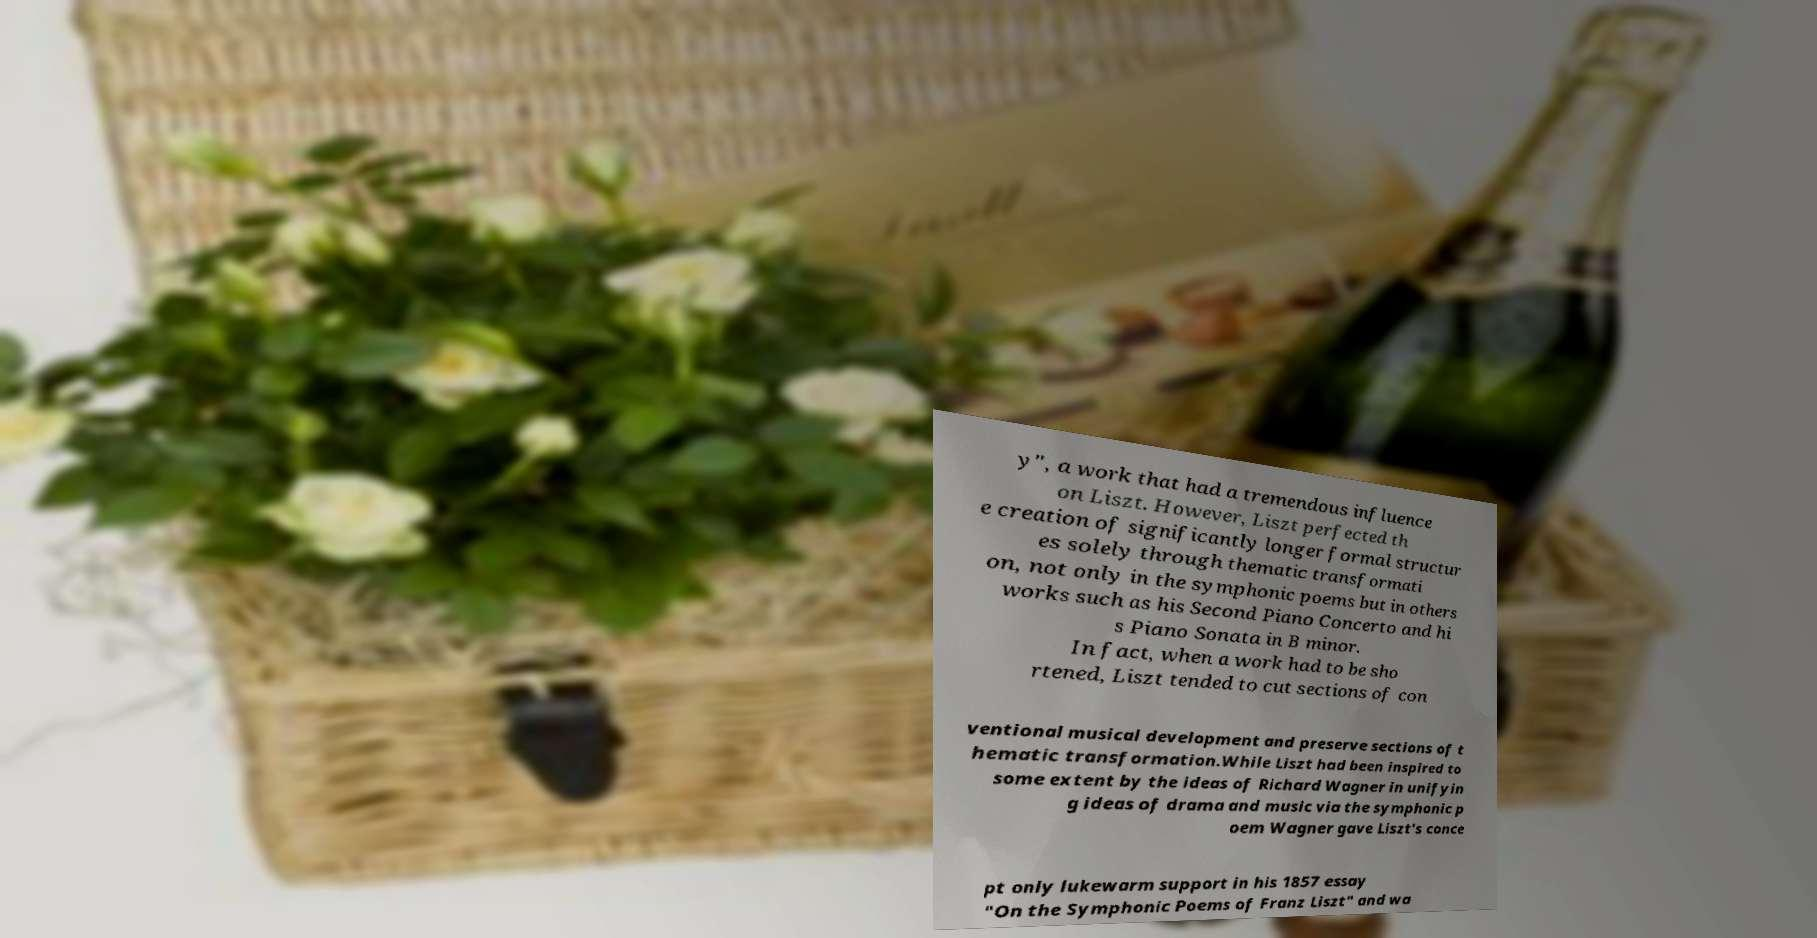What messages or text are displayed in this image? I need them in a readable, typed format. y", a work that had a tremendous influence on Liszt. However, Liszt perfected th e creation of significantly longer formal structur es solely through thematic transformati on, not only in the symphonic poems but in others works such as his Second Piano Concerto and hi s Piano Sonata in B minor. In fact, when a work had to be sho rtened, Liszt tended to cut sections of con ventional musical development and preserve sections of t hematic transformation.While Liszt had been inspired to some extent by the ideas of Richard Wagner in unifyin g ideas of drama and music via the symphonic p oem Wagner gave Liszt's conce pt only lukewarm support in his 1857 essay "On the Symphonic Poems of Franz Liszt" and wa 